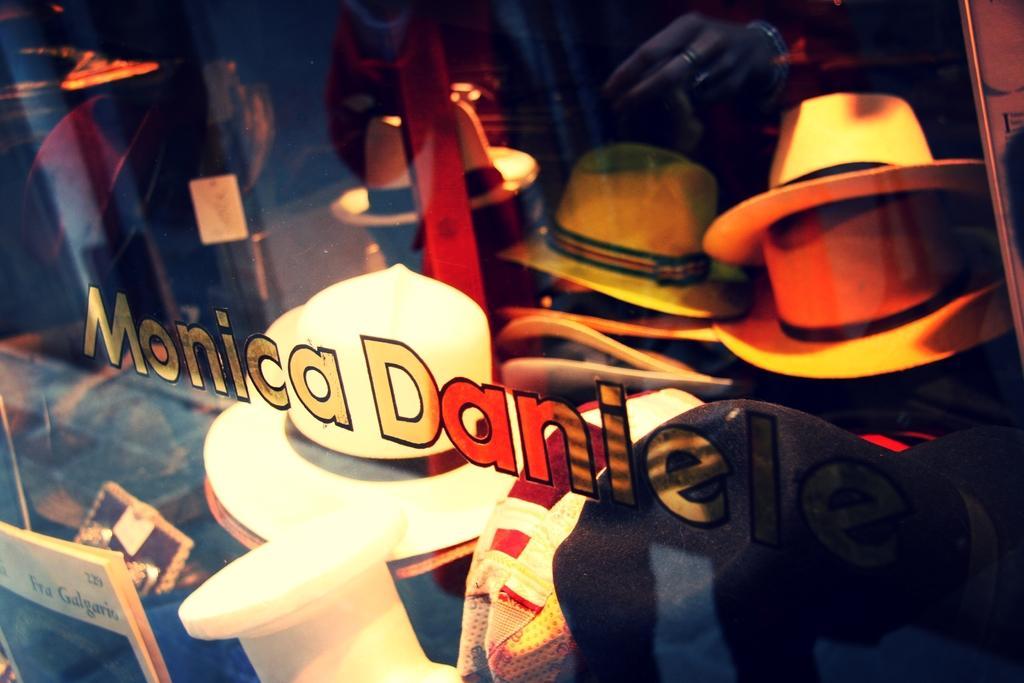In one or two sentences, can you explain what this image depicts? In this image I can see few hats in multi color and I can also see few objects. In front I can see the glass and I can see something written on the image. 